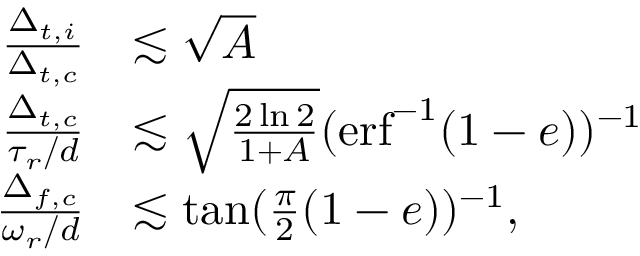Convert formula to latex. <formula><loc_0><loc_0><loc_500><loc_500>\begin{array} { r l } { \frac { \Delta _ { t , i } } { \Delta _ { t , c } } } & { \lesssim \sqrt { A } } \\ { \frac { \Delta _ { t , c } } { \tau _ { r } / d } } & { \lesssim \sqrt { \frac { 2 \ln { 2 } } { 1 + A } } ( e r f ^ { - 1 } ( 1 - e ) ) ^ { - 1 } } \\ { \frac { \Delta _ { f , c } } { \omega _ { r } / d } } & { \lesssim \tan ( \frac { \pi } { 2 } ( 1 - e ) ) ^ { - 1 } , } \end{array}</formula> 